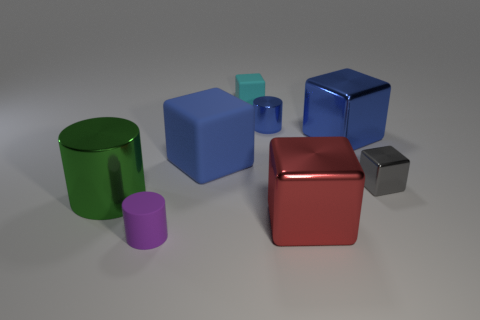What is the size of the purple rubber object that is the same shape as the green thing?
Make the answer very short. Small. There is a small thing that is right of the small blue metal thing; what is its shape?
Provide a short and direct response. Cube. There is a red shiny thing; is its shape the same as the tiny matte thing that is behind the small gray object?
Offer a terse response. Yes. Are there an equal number of large blue rubber cubes left of the green metal object and big green cylinders behind the red cube?
Your answer should be very brief. No. What is the shape of the big metal object that is the same color as the big matte block?
Your answer should be compact. Cube. Does the tiny metallic object that is behind the tiny gray object have the same color as the large metal block that is behind the tiny gray block?
Make the answer very short. Yes. Is the number of big blue rubber cubes that are in front of the blue metallic cylinder greater than the number of tiny brown balls?
Provide a short and direct response. Yes. What is the material of the cyan block?
Provide a short and direct response. Rubber. What shape is the big blue object that is the same material as the large green object?
Your answer should be compact. Cube. How big is the blue cube behind the rubber block that is on the left side of the small cyan block?
Offer a very short reply. Large. 